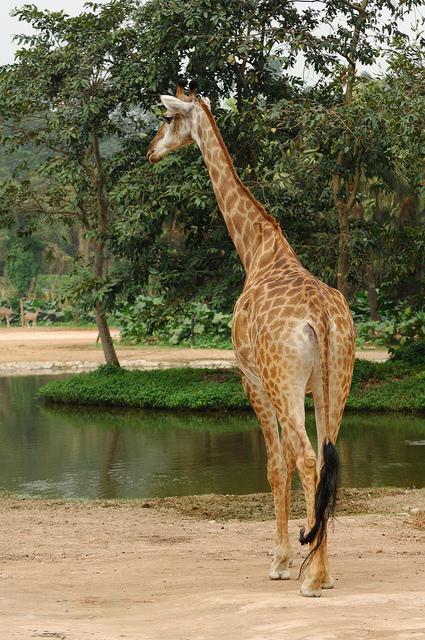How many elephants?
Quick response, please. 0. Is the area fenced?
Short answer required. No. Is the giraffe moving quickly?
Give a very brief answer. No. How tall is this giraffe in feet?
Short answer required. 12. 